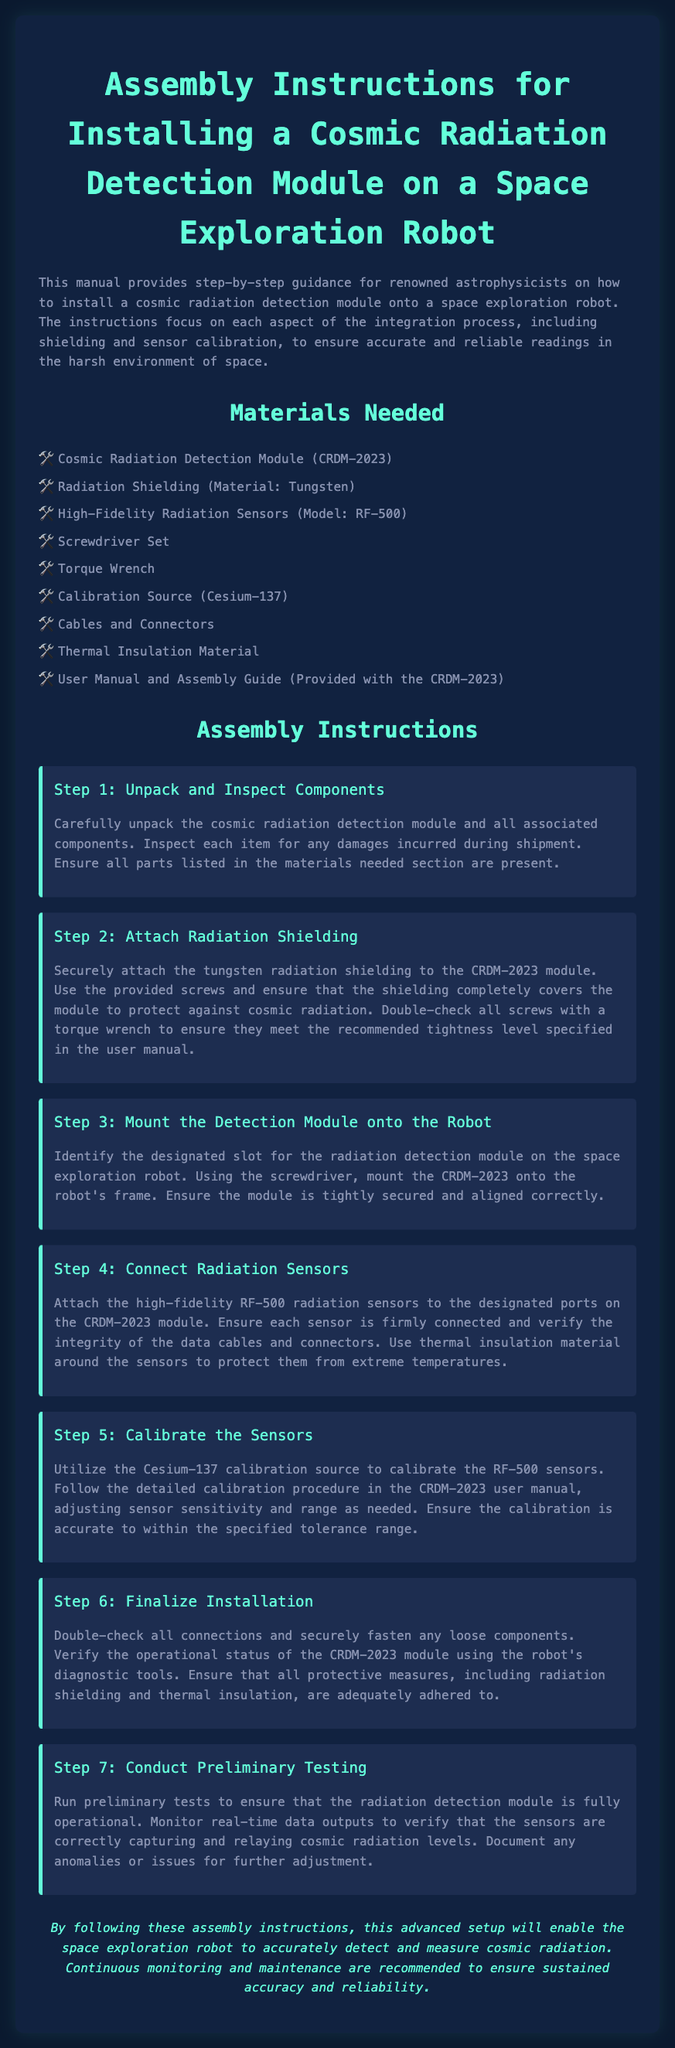What is the name of the radiation detection module? The name of the radiation detection module is explicitly stated in the title of the document.
Answer: Cosmic Radiation Detection Module (CRDM-2023) What material is used for radiation shielding? The document mentions the specific material used for radiation shielding.
Answer: Tungsten How many steps are included in the assembly instructions? The number of steps can be counted from the assembly section of the document.
Answer: 7 What is the model number of the high-fidelity radiation sensors? The model number is provided in the materials list.
Answer: RF-500 What calibration source is used in the installation? The calibration source is listed in the materials needed section.
Answer: Cesium-137 Why is thermal insulation material used? The reasoning can be inferred from the step detailing sensor connections and its purpose.
Answer: To protect sensors from extreme temperatures What should be done after mounting the detection module? The subsequent action is described in the assembly instructions.
Answer: Connect radiation sensors What is the purpose of the torque wrench? The function of this tool is mentioned in the assembly step involving shielding attachment.
Answer: To ensure screws meet recommended tightness level What does the user manual provide for the CRDM-2023? The purpose of the user manual is indicated in the materials needed section.
Answer: Assembly guide 